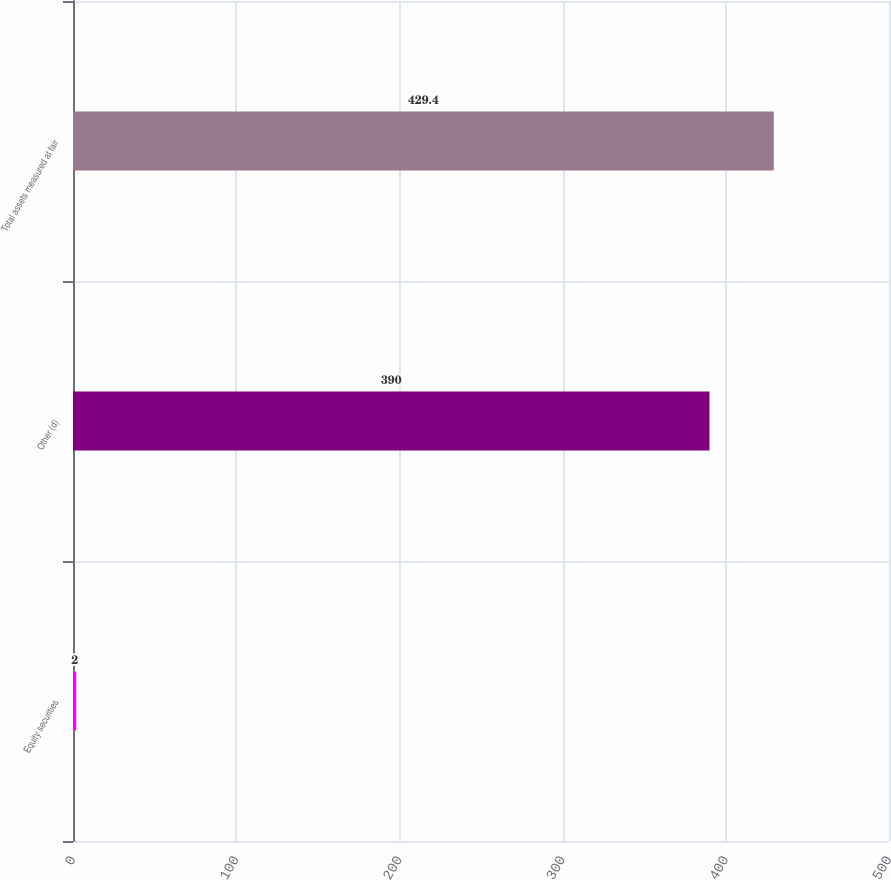Convert chart. <chart><loc_0><loc_0><loc_500><loc_500><bar_chart><fcel>Equity securities<fcel>Other (d)<fcel>Total assets measured at fair<nl><fcel>2<fcel>390<fcel>429.4<nl></chart> 